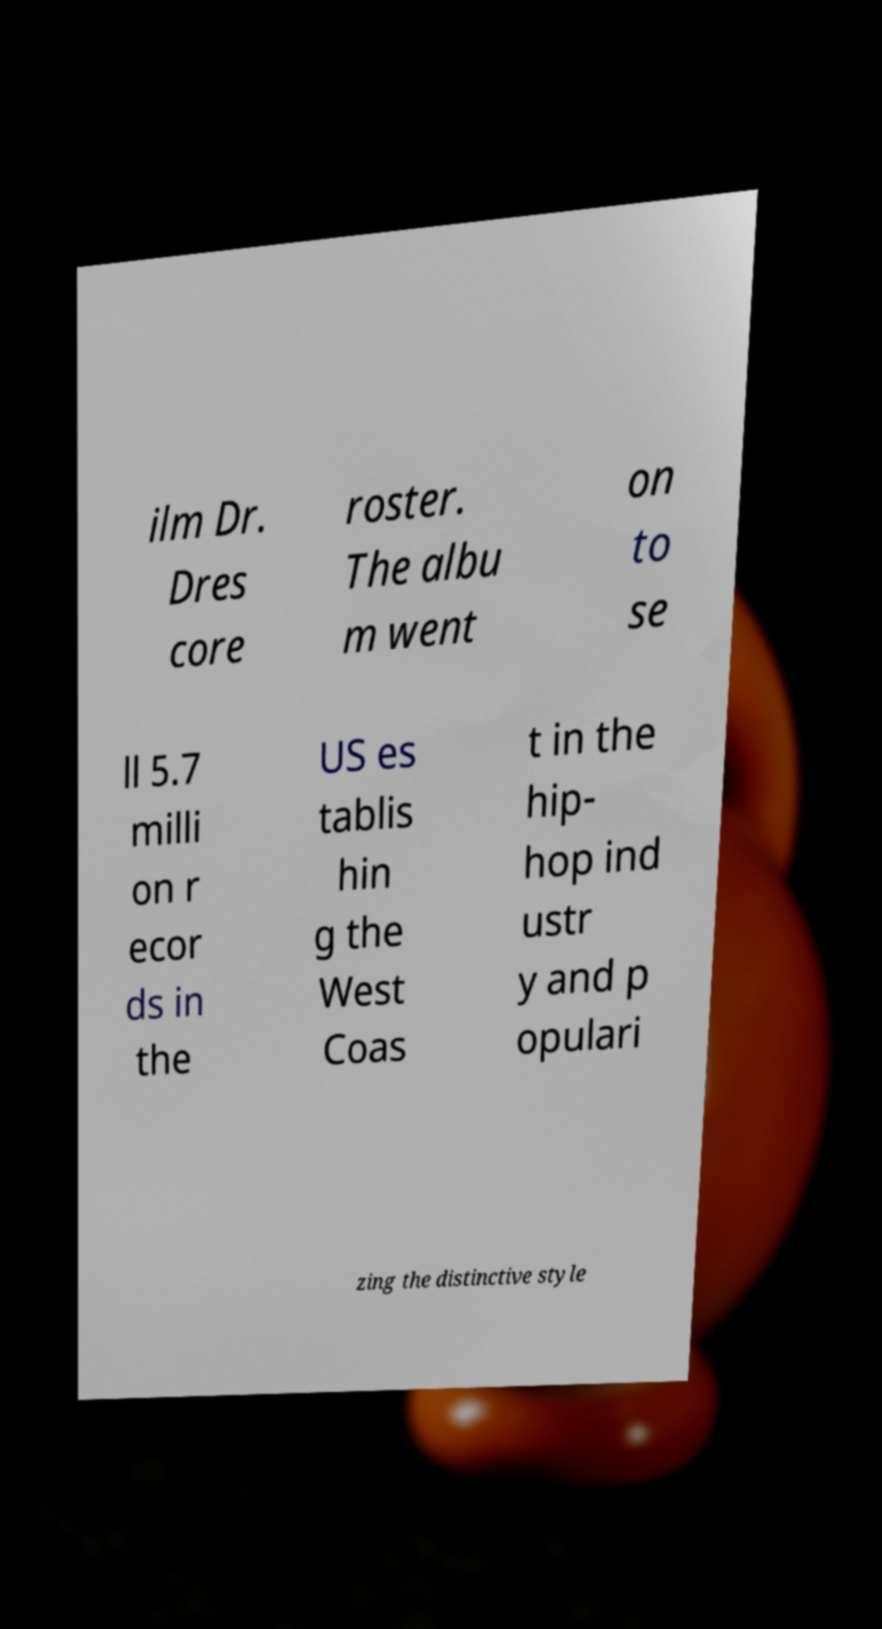Please identify and transcribe the text found in this image. ilm Dr. Dres core roster. The albu m went on to se ll 5.7 milli on r ecor ds in the US es tablis hin g the West Coas t in the hip- hop ind ustr y and p opulari zing the distinctive style 